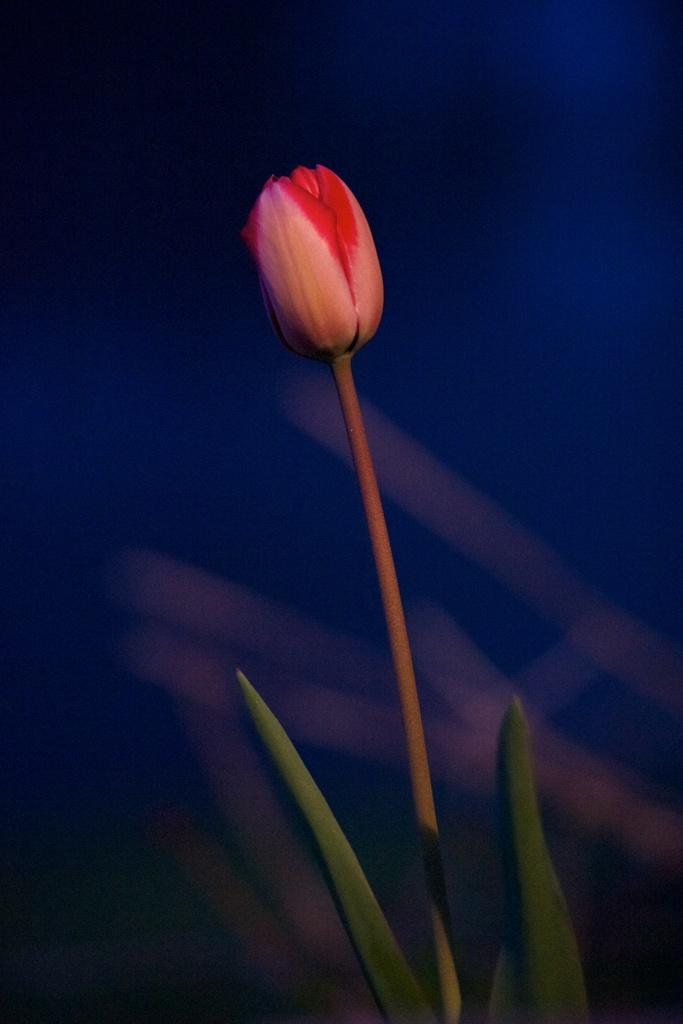What is the main subject of the image? The main subject of the image is a plant. What specific features can be observed on the plant? The plant has a flower and green leaves. How would you describe the background of the image? The background of the image is blurred. What type of scissors can be seen cutting the flower in the image? There are no scissors present in the image, and the flower is not being cut. What activity is the plant engaging in during the image? Plants do not engage in activities like humans do; they simply grow and develop. 